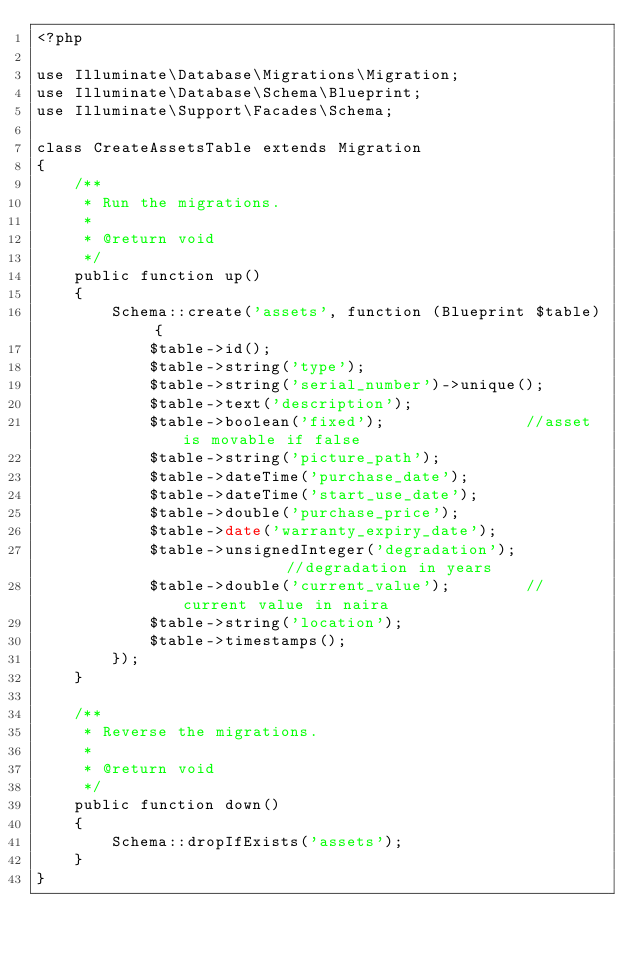<code> <loc_0><loc_0><loc_500><loc_500><_PHP_><?php

use Illuminate\Database\Migrations\Migration;
use Illuminate\Database\Schema\Blueprint;
use Illuminate\Support\Facades\Schema;

class CreateAssetsTable extends Migration
{
    /**
     * Run the migrations.
     *
     * @return void
     */
    public function up()
    {
        Schema::create('assets', function (Blueprint $table) {
            $table->id();
            $table->string('type');
            $table->string('serial_number')->unique();
            $table->text('description');
            $table->boolean('fixed');               //asset is movable if false
            $table->string('picture_path'); 
            $table->dateTime('purchase_date');
            $table->dateTime('start_use_date');
            $table->double('purchase_price');
            $table->date('warranty_expiry_date');
            $table->unsignedInteger('degradation');            //degradation in years
            $table->double('current_value');        //current value in naira
            $table->string('location');
            $table->timestamps();
        });
    }

    /**
     * Reverse the migrations.
     *
     * @return void
     */
    public function down()
    {
        Schema::dropIfExists('assets');
    }
}
</code> 